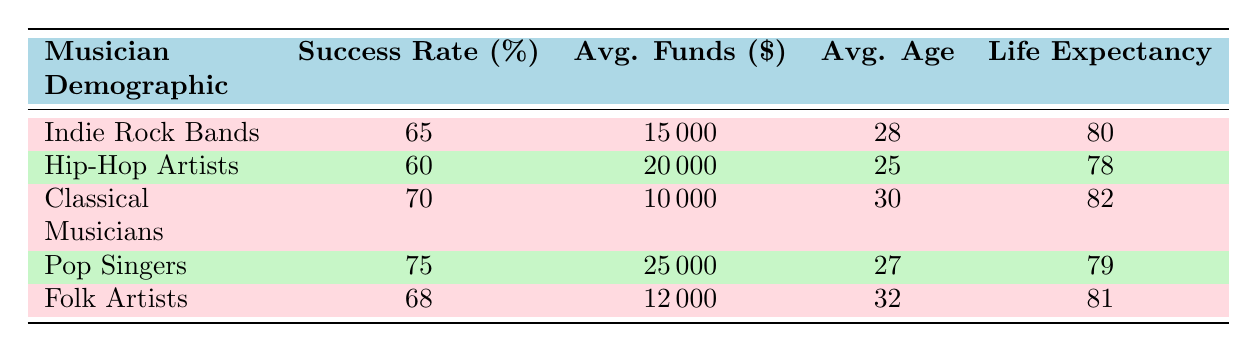What is the average success rate for Pop Singers? The table shows that the success rate for Pop Singers is listed as 75%.
Answer: 75% Which demographic has the highest average funds raised? The average funds raised for each demographic is as follows: Indie Rock Bands (15000), Hip-Hop Artists (20000), Classical Musicians (10000), Pop Singers (25000), and Folk Artists (12000). Pop Singers have the highest average funds raised at 25000.
Answer: 25000 Is the average age of Folk Artists older than that of Hip-Hop Artists? The average ages are: Folk Artists (32) and Hip-Hop Artists (25). Since 32 is greater than 25, Folk Artists are older.
Answer: Yes What is the difference in average success rates between Classical Musicians and Indie Rock Bands? The average success rates are: Classical Musicians (70) and Indie Rock Bands (65). The difference is calculated by subtracting: 70 - 65 = 5.
Answer: 5 What demographic has the lowest life expectancy? The life expectancies are as follows: Indie Rock Bands (80), Hip-Hop Artists (78), Classical Musicians (82), Pop Singers (79), and Folk Artists (81). The lowest life expectancy is for Hip-Hop Artists, which is 78.
Answer: 78 What is the average life expectancy for musicians in the table? To get the average life expectancy, we sum the life expectancies (80 + 78 + 82 + 79 + 81 = 400) and divide by the number of categories (5): 400/5 = 80.
Answer: 80 Do Hip-Hop Artists have a higher average success rate than Folk Artists? The average success rates are: Hip-Hop Artists (60) and Folk Artists (68). Since 60 is less than 68, Hip-Hop Artists do not have a higher success rate.
Answer: No Is it true that Classical Musicians raised more average funds than Indie Rock Bands? The average funds raised are: Classical Musicians (10000) and Indie Rock Bands (15000). Since 10000 is less than 15000, the statement is false.
Answer: No 